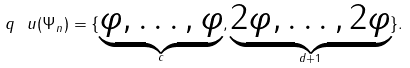Convert formula to latex. <formula><loc_0><loc_0><loc_500><loc_500>q _ { \ } u ( \Psi _ { n } ) = \{ \underbrace { \varphi , \dots , \varphi } _ { c } , \underbrace { 2 \varphi , \dots , 2 \varphi } _ { d + 1 } \} .</formula> 